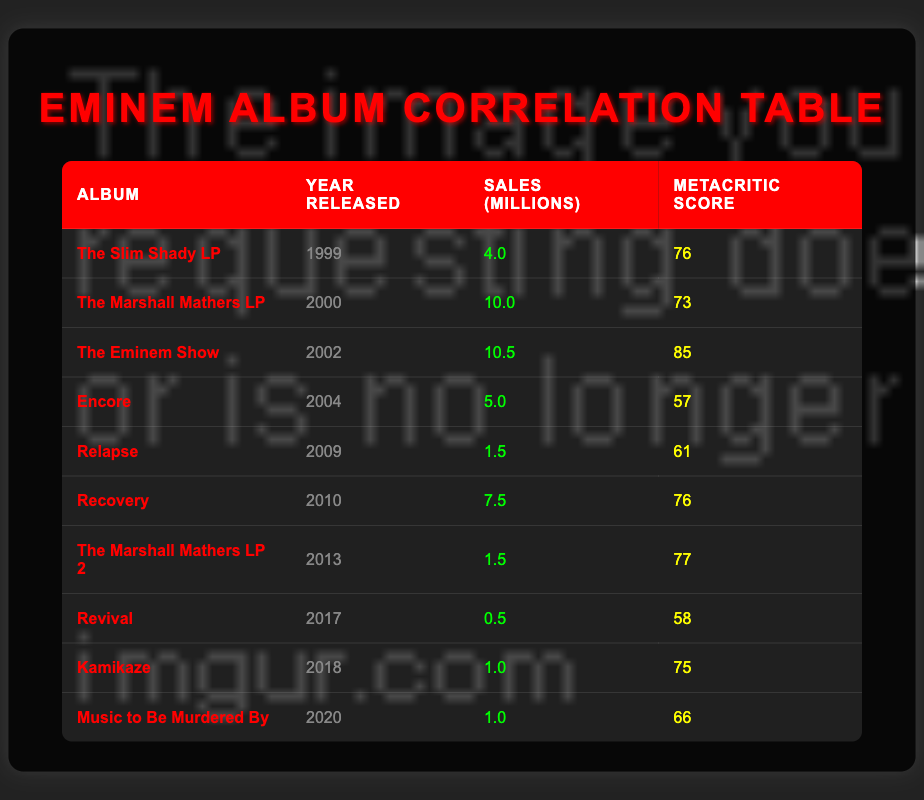What is the Metacritic score for "The Marshall Mathers LP"? Looking at the row for "The Marshall Mathers LP," the Metacritic Score listed is 73.
Answer: 73 What year was "Encore" released? The row for "Encore" shows it was released in 2004.
Answer: 2004 Which album has the highest sales? The album with the highest sales is "The Eminem Show" with 10.5 million.
Answer: The Eminem Show What is the average Metacritic score of all the albums? To find the average, we sum the Metacritic scores: (76 + 73 + 85 + 57 + 61 + 76 + 77 + 58 + 75 + 66) =  764. There are 10 albums, so the average is 764/10 = 76.4.
Answer: 76.4 Is "Kamikaze" rated higher than "Revival" on Metacritic? "Kamikaze" has a score of 75 while "Revival" has a score of 58. Since 75 is greater than 58, the answer is yes.
Answer: Yes Which album had lower sales than "Recovery"? "Relapse," "Revival," and "Kamikaze" had lower sales than "Recovery," which had 7.5 million. The sales were 1.5 million, 0.5 million, and 1.0 million for those albums respectively.
Answer: Relapse, Revival, Kamikaze How many albums have a Metacritic score above 75? The albums with scores above 75 are "The Eminem Show," "Recovery," and "The Marshall Mathers LP 2," totaling 3 albums.
Answer: 3 Which album released in 2010 has higher sales than the lowest selling album? "Recovery," released in 2010, has sales of 7.5 million, which is higher than "Revival," the lowest-selling album with 0.5 million.
Answer: Recovery What is the difference in sales between "The Slim Shady LP" and "Encore"? "The Slim Shady LP" has sales of 4.0 million and "Encore" has sales of 5.0 million. The difference is 5.0 - 4.0 = 1.0 million.
Answer: 1.0 million 